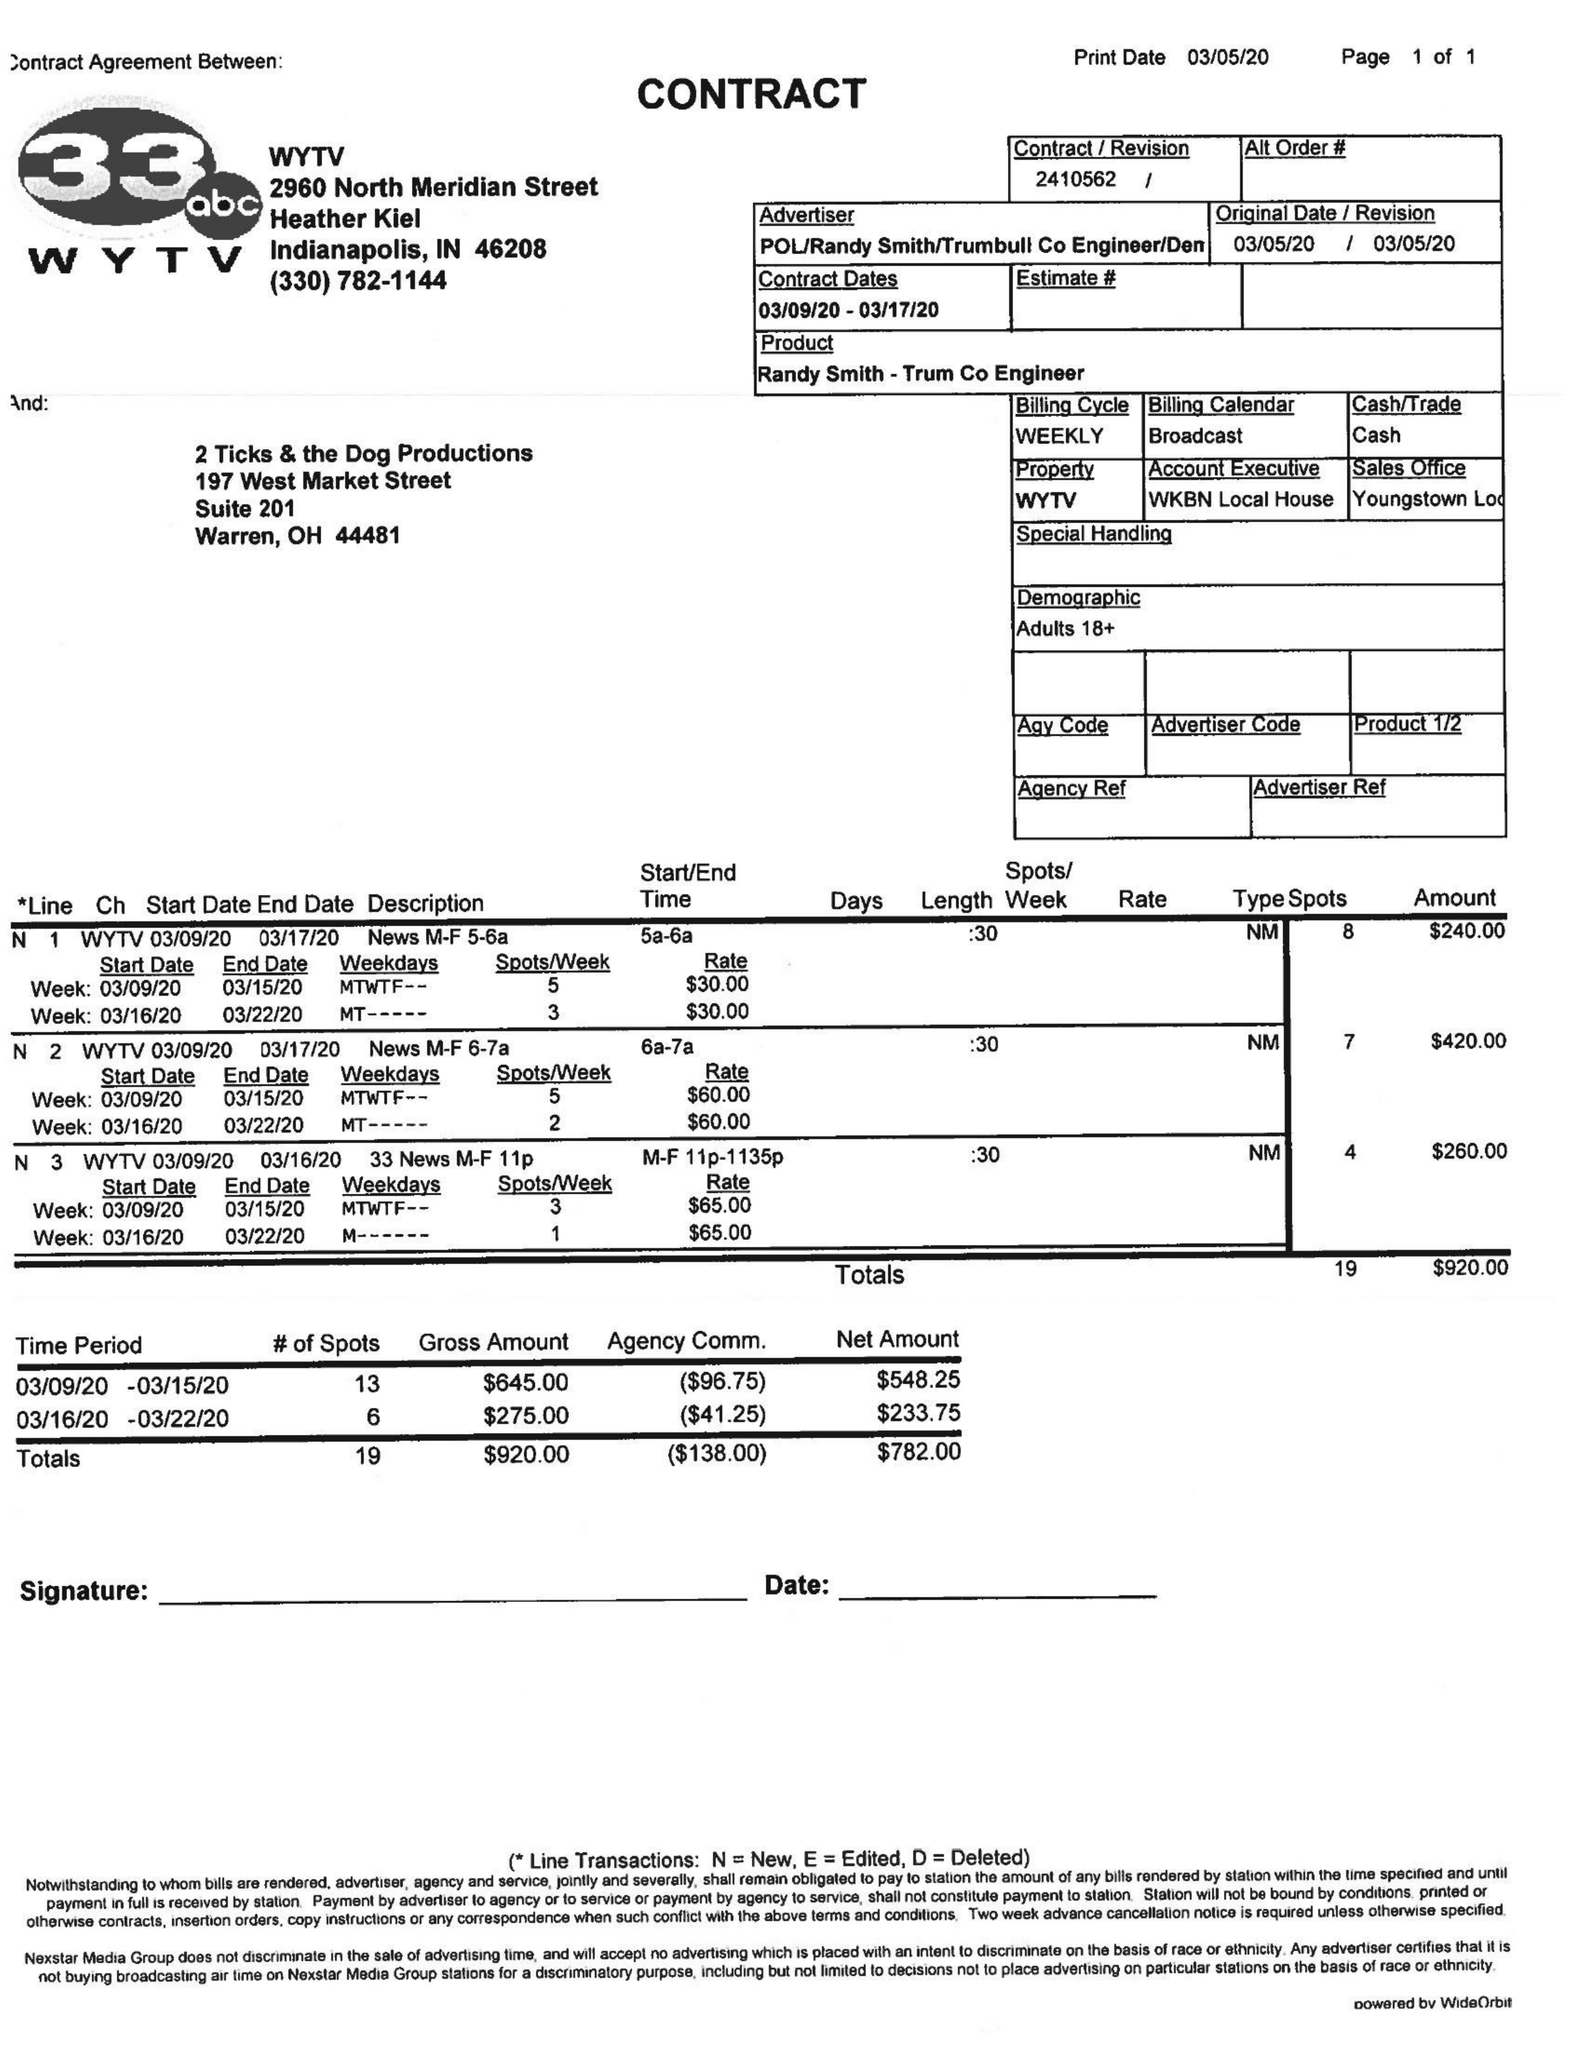What is the value for the flight_to?
Answer the question using a single word or phrase. 03/17/20 